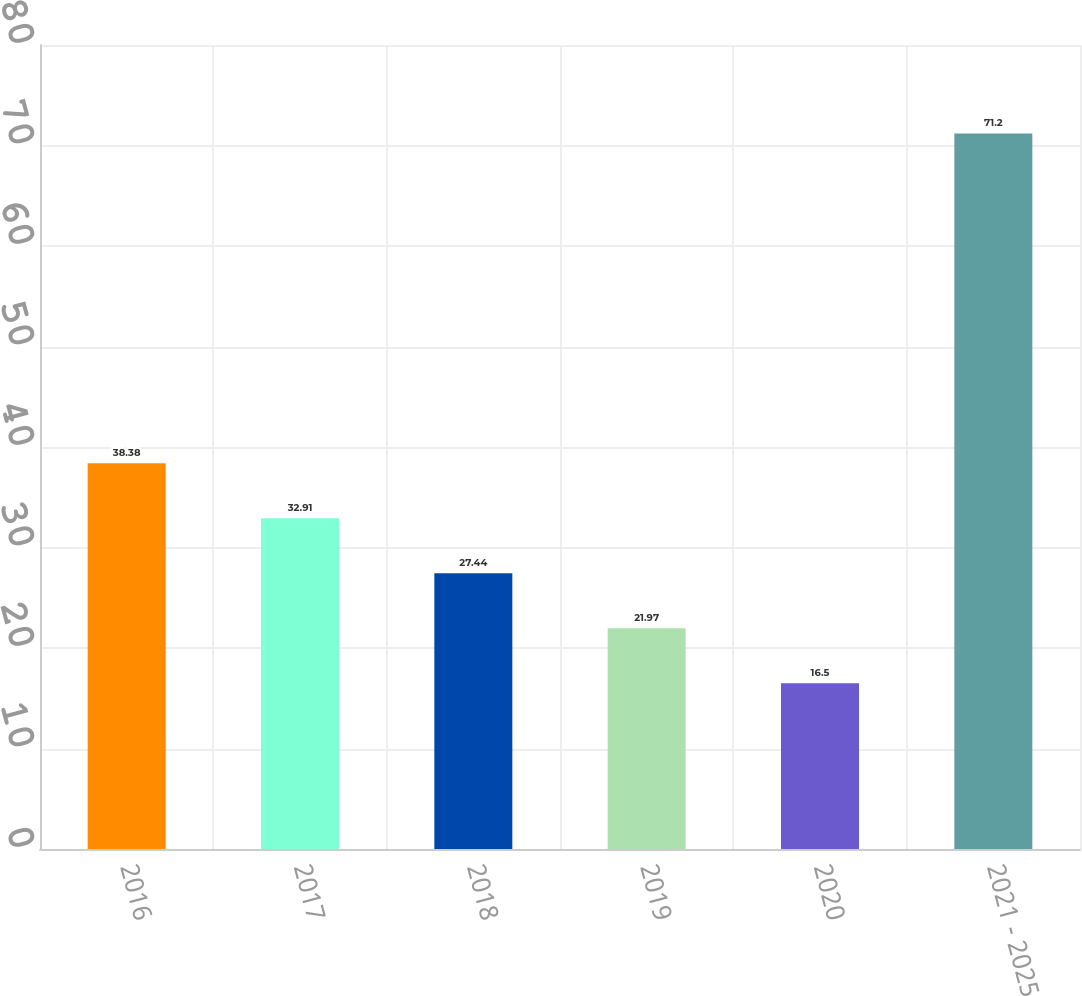Convert chart to OTSL. <chart><loc_0><loc_0><loc_500><loc_500><bar_chart><fcel>2016<fcel>2017<fcel>2018<fcel>2019<fcel>2020<fcel>2021 - 2025<nl><fcel>38.38<fcel>32.91<fcel>27.44<fcel>21.97<fcel>16.5<fcel>71.2<nl></chart> 